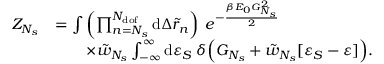<formula> <loc_0><loc_0><loc_500><loc_500>\begin{array} { r l } { Z _ { N _ { s } } } & { = \int { \left ( \prod _ { n = N _ { s } } ^ { N _ { d o f } } { d \Delta \tilde { r } _ { n } } \right ) \, e ^ { - \frac { \beta E _ { 0 } G _ { N _ { s } } ^ { 2 } } { 2 } } } } \\ & { \quad \times \tilde { w } _ { N _ { s } } \int _ { - \infty } ^ { \infty } { d \varepsilon _ { S } \, \delta \left ( G _ { N _ { s } } + \tilde { w } _ { N _ { s } } [ \varepsilon _ { S } - \varepsilon ] \right ) } . } \end{array}</formula> 